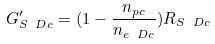Convert formula to latex. <formula><loc_0><loc_0><loc_500><loc_500>G ^ { \prime } _ { S \ D c } = ( 1 - \frac { n _ { p c } } { n _ { e _ { \ } D c } } ) R _ { S \ D c }</formula> 